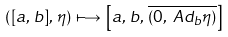<formula> <loc_0><loc_0><loc_500><loc_500>\left ( [ a , \, b ] , \, \eta \right ) & \, \longmapsto \, \left [ a , \, b , \, \overline { ( 0 , \ A d _ { b } \eta ) } \right ]</formula> 